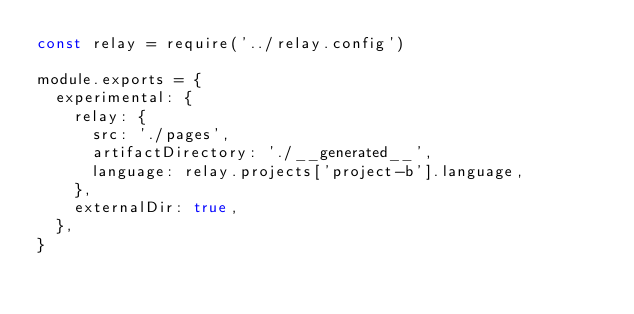<code> <loc_0><loc_0><loc_500><loc_500><_JavaScript_>const relay = require('../relay.config')

module.exports = {
  experimental: {
    relay: {
      src: './pages',
      artifactDirectory: './__generated__',
      language: relay.projects['project-b'].language,
    },
    externalDir: true,
  },
}
</code> 